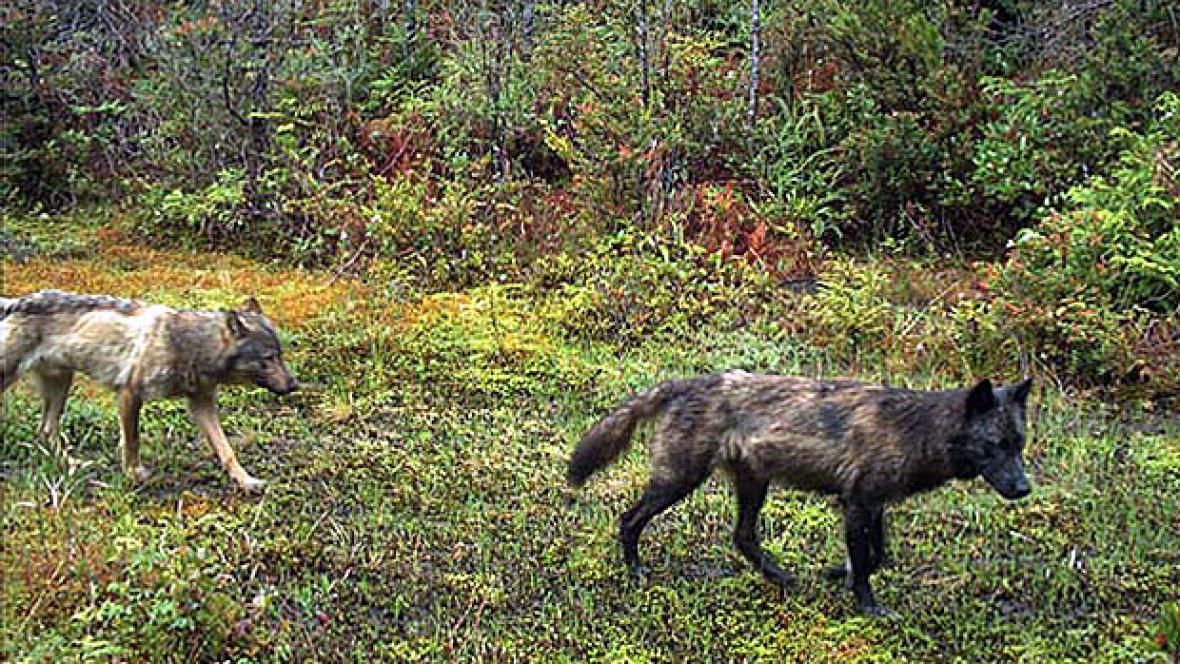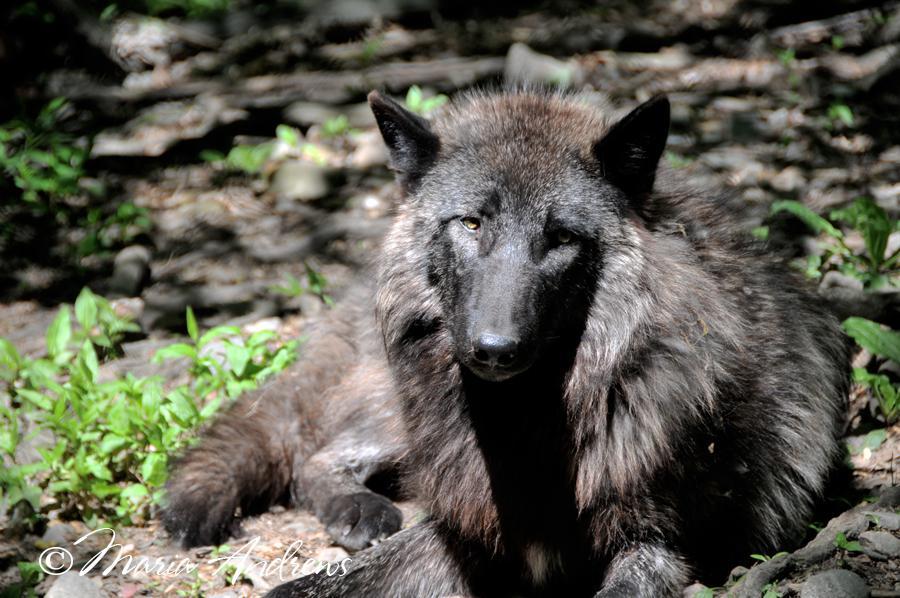The first image is the image on the left, the second image is the image on the right. Evaluate the accuracy of this statement regarding the images: "At least one of the wild dogs is laying down and none are in snow.". Is it true? Answer yes or no. Yes. 